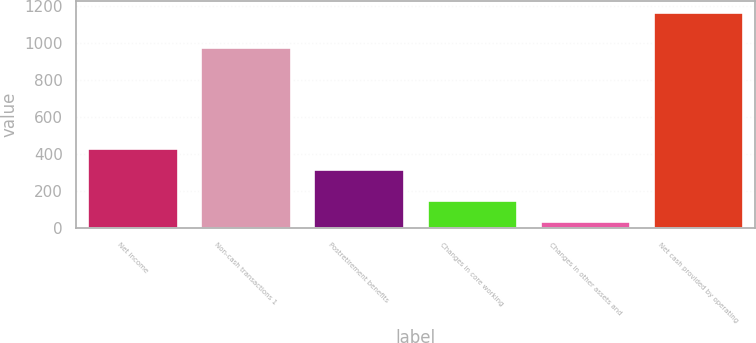Convert chart. <chart><loc_0><loc_0><loc_500><loc_500><bar_chart><fcel>Net income<fcel>Non-cash transactions 1<fcel>Postretirement benefits<fcel>Changes in core working<fcel>Changes in other assets and<fcel>Net cash provided by operating<nl><fcel>435.8<fcel>981<fcel>323<fcel>153.8<fcel>41<fcel>1169<nl></chart> 